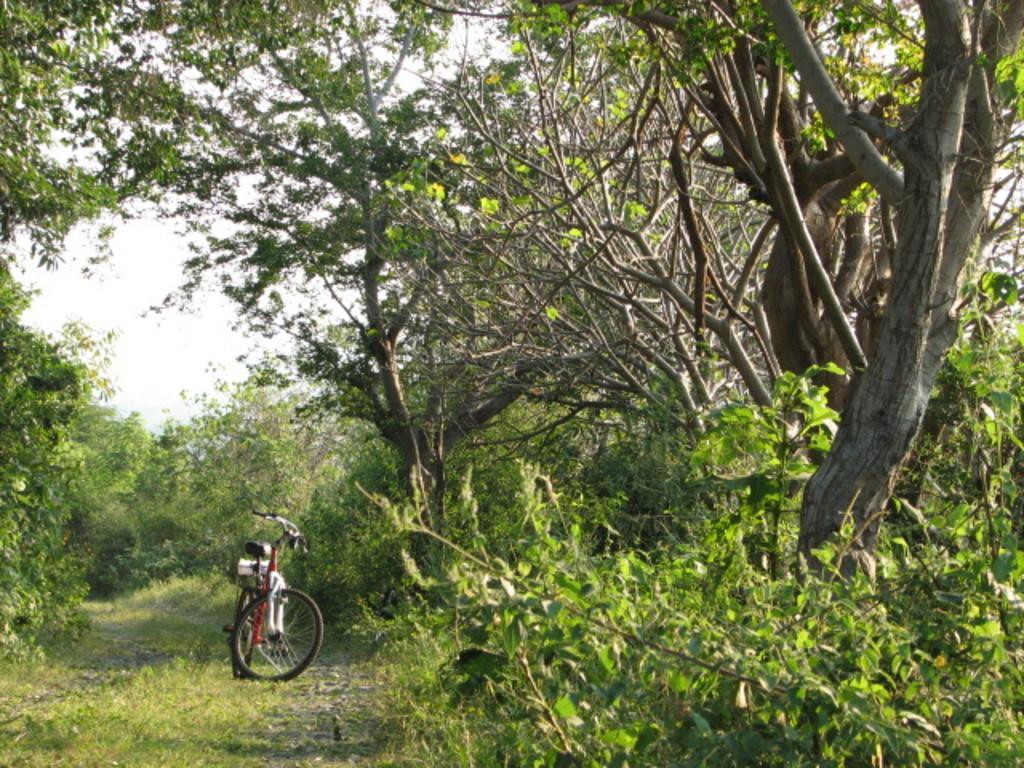Please provide a concise description of this image. In this image we can see a bicycle and there are trees. At the bottom there is grass. In the background there is sky and we can see plants. 